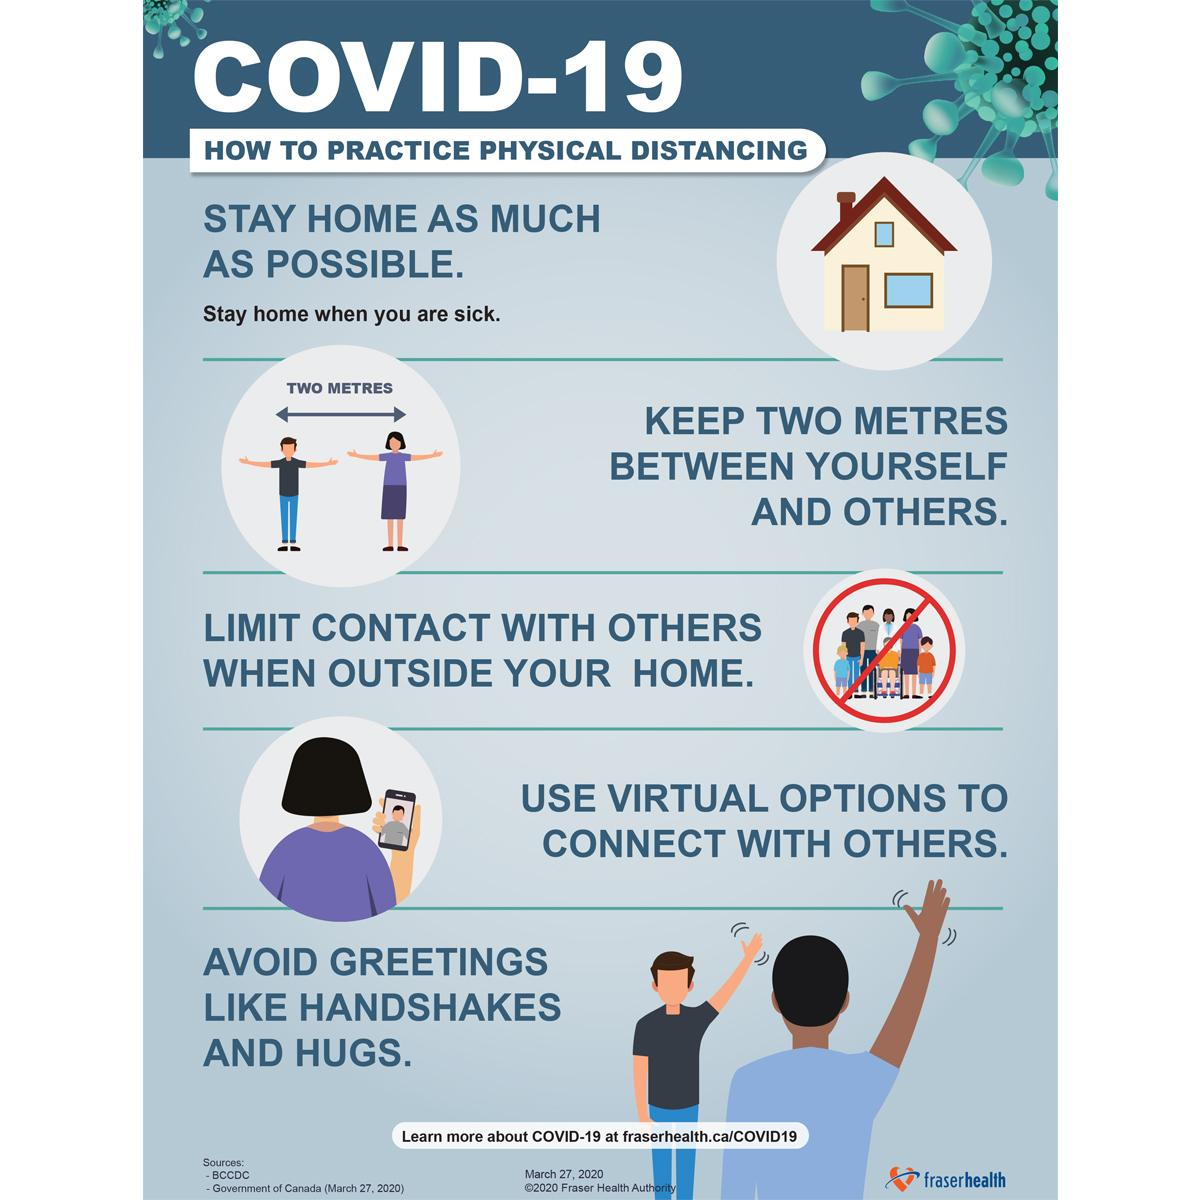Specify some key components in this picture. It is important to avoid certain activities and limit contact with others during times of social distancing, staying home, and limiting contact in order to reduce the spread of infectious diseases. The distance between the man and the woman is approximately two metres. 